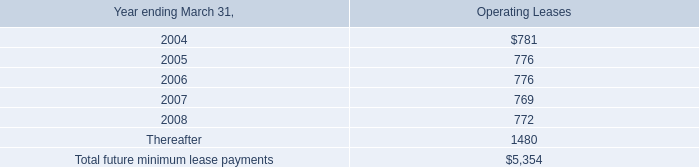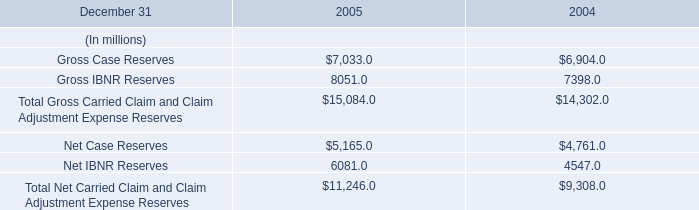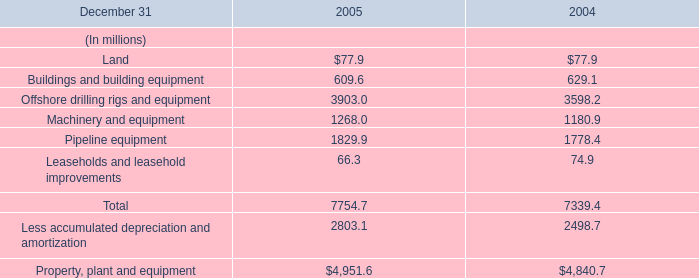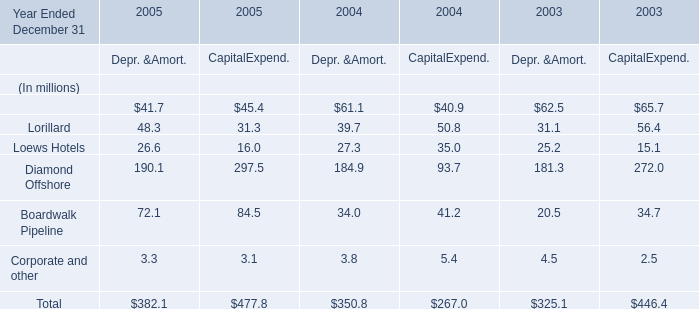What is the sum of Depr. &Amort. in the range of 0 and 30 in 2004？ (in million) 
Computations: (27.3 + 3.8)
Answer: 31.1. 